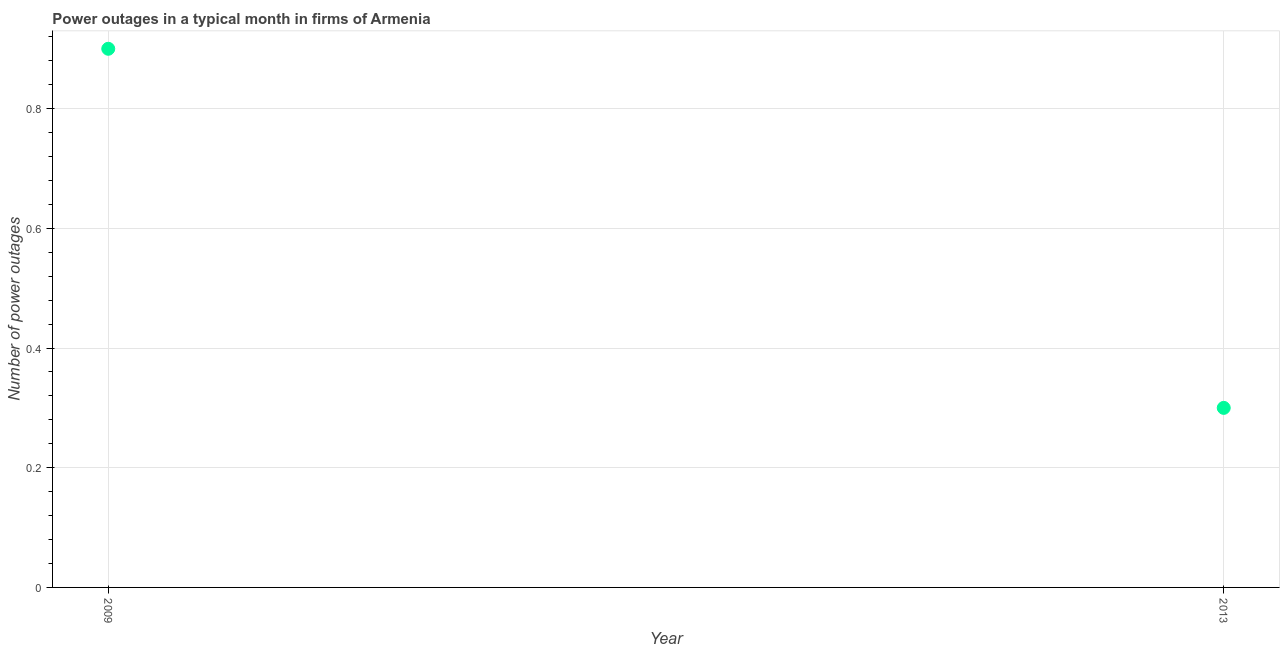What is the number of power outages in 2013?
Offer a terse response. 0.3. Across all years, what is the maximum number of power outages?
Provide a short and direct response. 0.9. Across all years, what is the minimum number of power outages?
Offer a terse response. 0.3. In which year was the number of power outages maximum?
Offer a terse response. 2009. In which year was the number of power outages minimum?
Provide a succinct answer. 2013. What is the sum of the number of power outages?
Keep it short and to the point. 1.2. What is the difference between the number of power outages in 2009 and 2013?
Offer a terse response. 0.6. What is the average number of power outages per year?
Provide a short and direct response. 0.6. What is the median number of power outages?
Make the answer very short. 0.6. Do a majority of the years between 2009 and 2013 (inclusive) have number of power outages greater than 0.88 ?
Provide a short and direct response. No. Is the number of power outages in 2009 less than that in 2013?
Offer a very short reply. No. Does the number of power outages monotonically increase over the years?
Your response must be concise. No. How many years are there in the graph?
Offer a terse response. 2. Are the values on the major ticks of Y-axis written in scientific E-notation?
Give a very brief answer. No. What is the title of the graph?
Your answer should be compact. Power outages in a typical month in firms of Armenia. What is the label or title of the X-axis?
Ensure brevity in your answer.  Year. What is the label or title of the Y-axis?
Provide a short and direct response. Number of power outages. What is the Number of power outages in 2009?
Your answer should be compact. 0.9. 